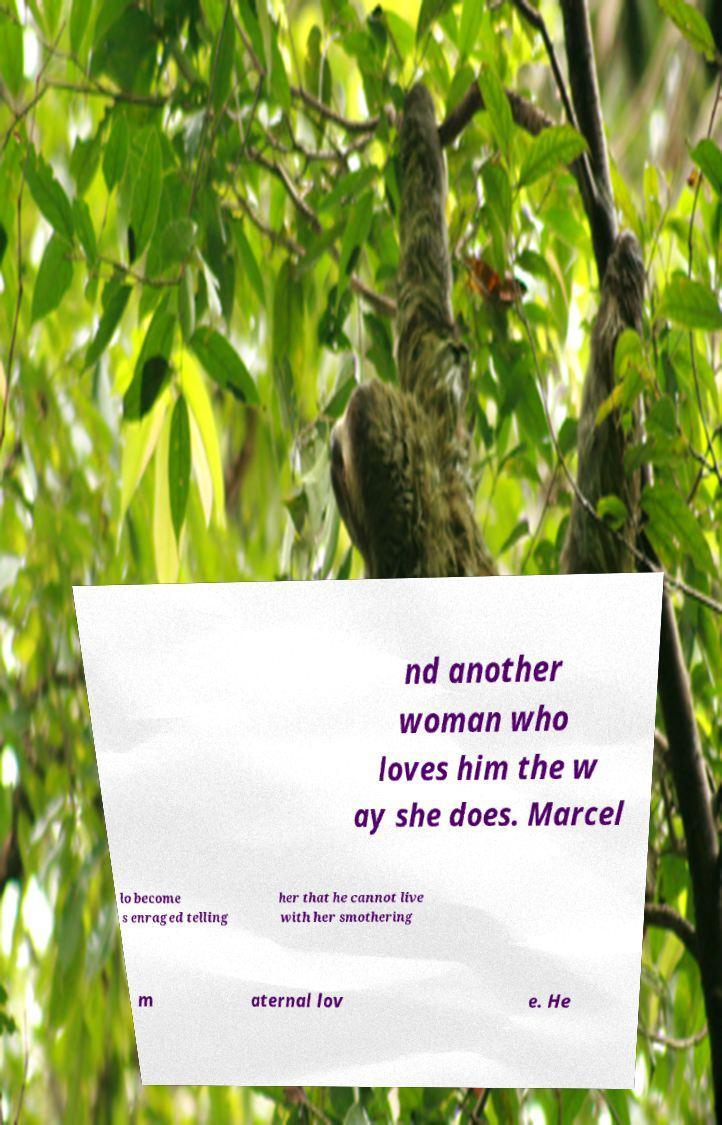For documentation purposes, I need the text within this image transcribed. Could you provide that? nd another woman who loves him the w ay she does. Marcel lo become s enraged telling her that he cannot live with her smothering m aternal lov e. He 